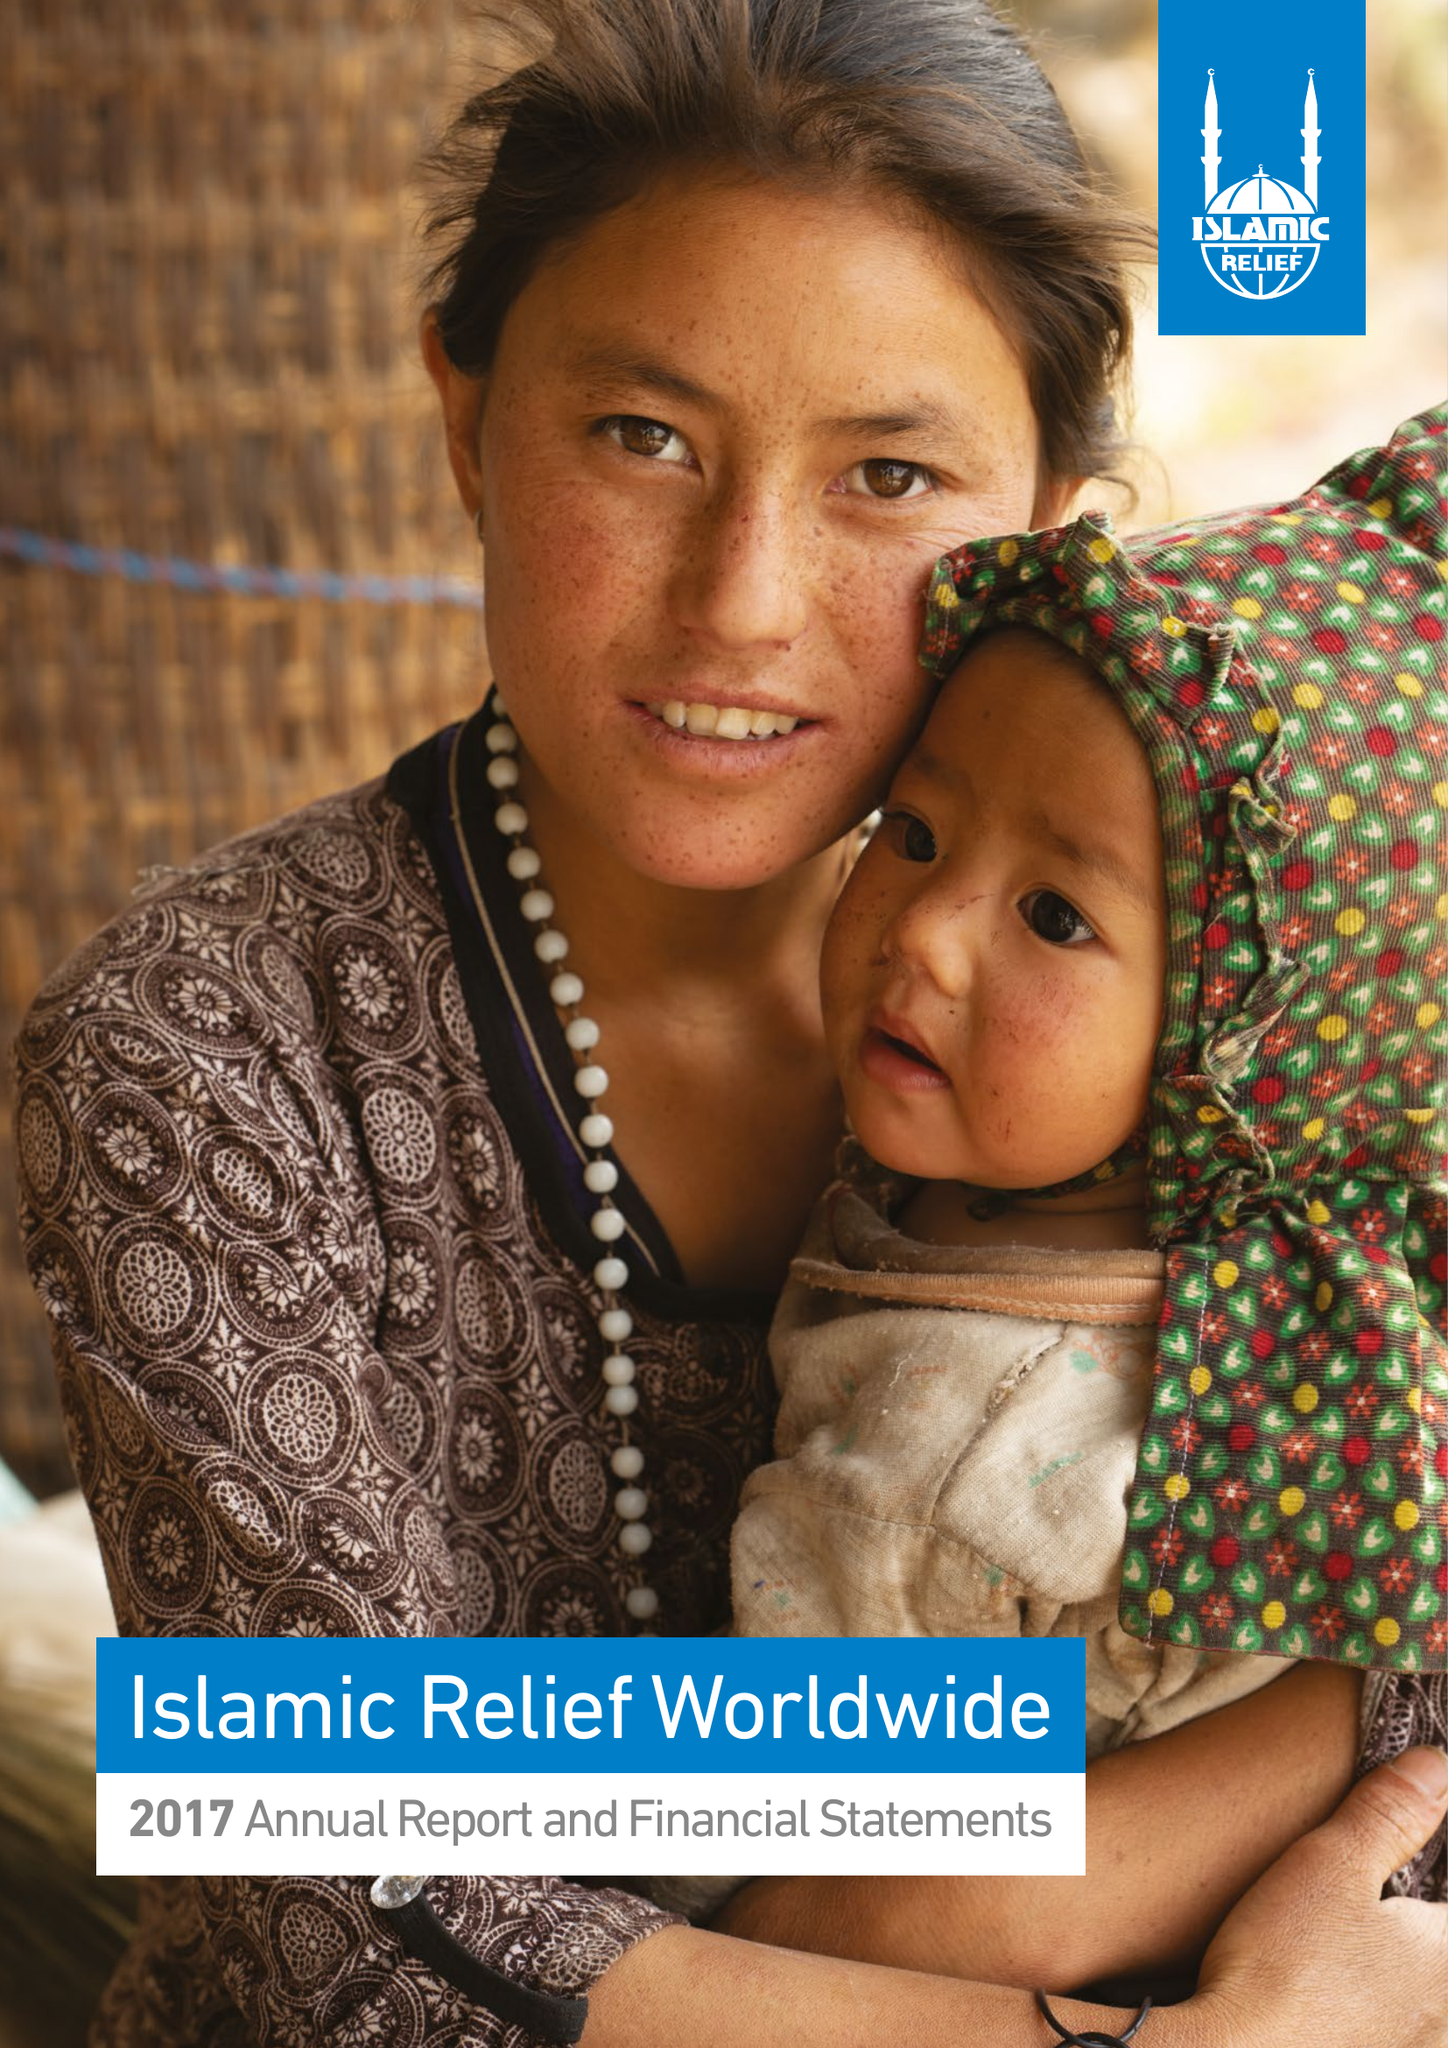What is the value for the report_date?
Answer the question using a single word or phrase. 2017-12-31 